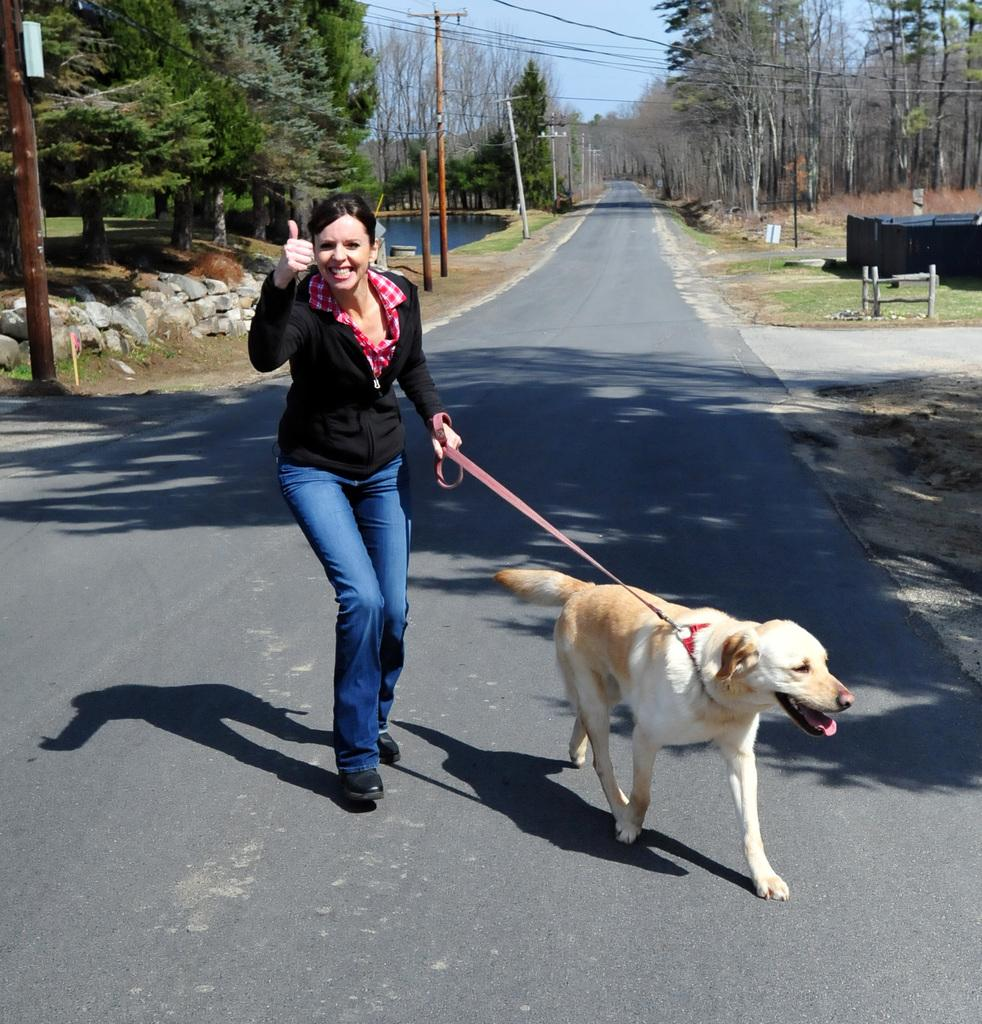Who is present in the image? There is a woman in the image. What is the woman holding in the image? The woman is holding a dog's leash in the image. What animal is present in the image? The dog is present in the image. Where are they located in the image? They are on the road in the image. What can be seen in the background of the image? There are trees, poles, the sky, and water visible in the background of the image. What type of copper jar can be seen on the lamp in the image? There is no copper jar or lamp present in the image. 